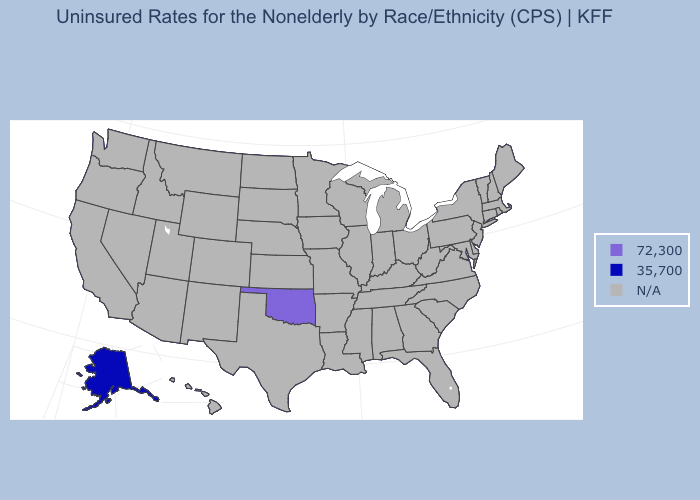Name the states that have a value in the range 35,700?
Be succinct. Alaska. Which states have the lowest value in the USA?
Be succinct. Alaska. What is the value of Georgia?
Quick response, please. N/A. What is the lowest value in the West?
Be succinct. 35,700. Name the states that have a value in the range N/A?
Quick response, please. Alabama, Arizona, Arkansas, California, Colorado, Connecticut, Delaware, Florida, Georgia, Hawaii, Idaho, Illinois, Indiana, Iowa, Kansas, Kentucky, Louisiana, Maine, Maryland, Massachusetts, Michigan, Minnesota, Mississippi, Missouri, Montana, Nebraska, Nevada, New Hampshire, New Jersey, New Mexico, New York, North Carolina, North Dakota, Ohio, Oregon, Pennsylvania, Rhode Island, South Carolina, South Dakota, Tennessee, Texas, Utah, Vermont, Virginia, Washington, West Virginia, Wisconsin, Wyoming. What is the value of New Mexico?
Short answer required. N/A. What is the value of North Carolina?
Keep it brief. N/A. Name the states that have a value in the range 35,700?
Be succinct. Alaska. Which states have the lowest value in the USA?
Keep it brief. Alaska. 